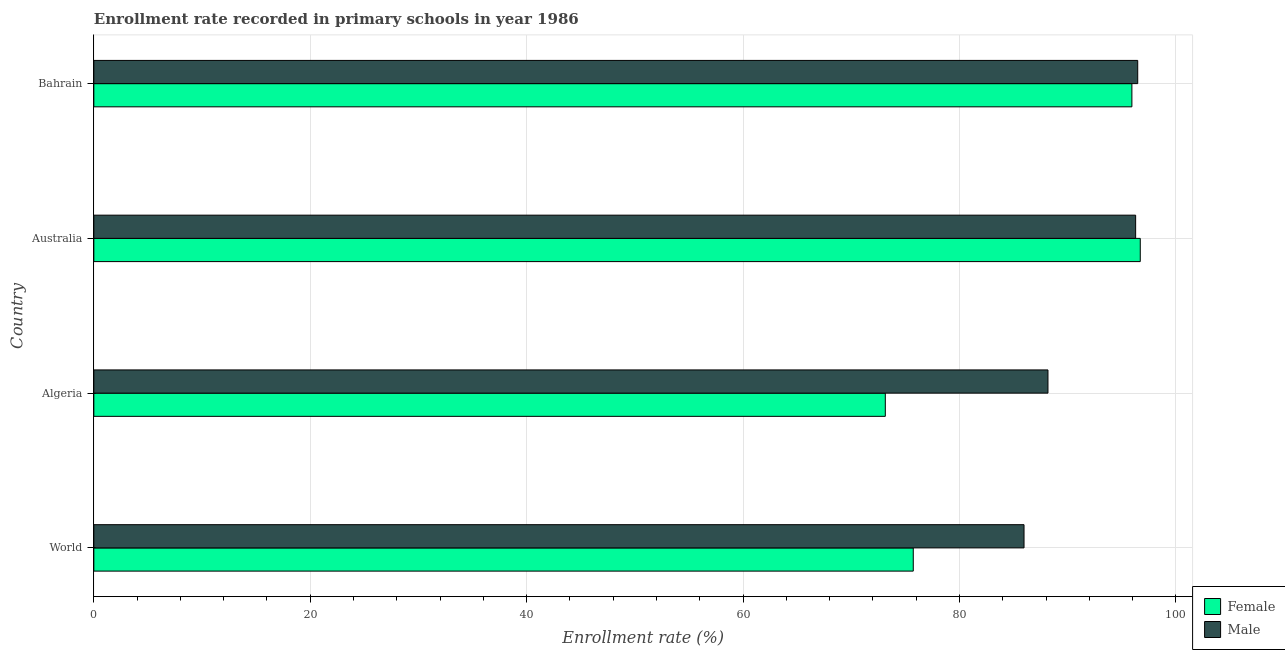How many groups of bars are there?
Make the answer very short. 4. What is the label of the 4th group of bars from the top?
Provide a succinct answer. World. What is the enrollment rate of male students in World?
Provide a succinct answer. 85.96. Across all countries, what is the maximum enrollment rate of male students?
Keep it short and to the point. 96.47. Across all countries, what is the minimum enrollment rate of male students?
Offer a very short reply. 85.96. In which country was the enrollment rate of male students maximum?
Your answer should be very brief. Bahrain. In which country was the enrollment rate of female students minimum?
Your answer should be compact. Algeria. What is the total enrollment rate of male students in the graph?
Offer a very short reply. 366.88. What is the difference between the enrollment rate of female students in Algeria and that in World?
Give a very brief answer. -2.58. What is the difference between the enrollment rate of female students in Australia and the enrollment rate of male students in Algeria?
Offer a terse response. 8.53. What is the average enrollment rate of male students per country?
Make the answer very short. 91.72. What is the difference between the enrollment rate of female students and enrollment rate of male students in Australia?
Your answer should be very brief. 0.43. In how many countries, is the enrollment rate of female students greater than 68 %?
Offer a terse response. 4. What is the ratio of the enrollment rate of female students in Australia to that in World?
Offer a very short reply. 1.28. Is the enrollment rate of male students in Bahrain less than that in World?
Make the answer very short. No. What is the difference between the highest and the second highest enrollment rate of male students?
Make the answer very short. 0.19. What is the difference between the highest and the lowest enrollment rate of female students?
Give a very brief answer. 23.56. In how many countries, is the enrollment rate of male students greater than the average enrollment rate of male students taken over all countries?
Make the answer very short. 2. Is the sum of the enrollment rate of female students in Algeria and Bahrain greater than the maximum enrollment rate of male students across all countries?
Make the answer very short. Yes. Are all the bars in the graph horizontal?
Provide a short and direct response. Yes. How many countries are there in the graph?
Offer a terse response. 4. How many legend labels are there?
Offer a very short reply. 2. How are the legend labels stacked?
Make the answer very short. Vertical. What is the title of the graph?
Ensure brevity in your answer.  Enrollment rate recorded in primary schools in year 1986. What is the label or title of the X-axis?
Make the answer very short. Enrollment rate (%). What is the label or title of the Y-axis?
Offer a very short reply. Country. What is the Enrollment rate (%) of Female in World?
Give a very brief answer. 75.73. What is the Enrollment rate (%) in Male in World?
Your answer should be compact. 85.96. What is the Enrollment rate (%) in Female in Algeria?
Offer a terse response. 73.14. What is the Enrollment rate (%) of Male in Algeria?
Offer a terse response. 88.17. What is the Enrollment rate (%) of Female in Australia?
Your response must be concise. 96.7. What is the Enrollment rate (%) in Male in Australia?
Your response must be concise. 96.28. What is the Enrollment rate (%) in Female in Bahrain?
Keep it short and to the point. 95.93. What is the Enrollment rate (%) of Male in Bahrain?
Provide a succinct answer. 96.47. Across all countries, what is the maximum Enrollment rate (%) of Female?
Make the answer very short. 96.7. Across all countries, what is the maximum Enrollment rate (%) in Male?
Your response must be concise. 96.47. Across all countries, what is the minimum Enrollment rate (%) in Female?
Offer a very short reply. 73.14. Across all countries, what is the minimum Enrollment rate (%) in Male?
Keep it short and to the point. 85.96. What is the total Enrollment rate (%) of Female in the graph?
Keep it short and to the point. 341.5. What is the total Enrollment rate (%) in Male in the graph?
Keep it short and to the point. 366.88. What is the difference between the Enrollment rate (%) in Female in World and that in Algeria?
Give a very brief answer. 2.58. What is the difference between the Enrollment rate (%) in Male in World and that in Algeria?
Provide a succinct answer. -2.21. What is the difference between the Enrollment rate (%) in Female in World and that in Australia?
Make the answer very short. -20.98. What is the difference between the Enrollment rate (%) in Male in World and that in Australia?
Your response must be concise. -10.31. What is the difference between the Enrollment rate (%) in Female in World and that in Bahrain?
Provide a succinct answer. -20.2. What is the difference between the Enrollment rate (%) of Male in World and that in Bahrain?
Ensure brevity in your answer.  -10.51. What is the difference between the Enrollment rate (%) in Female in Algeria and that in Australia?
Offer a very short reply. -23.56. What is the difference between the Enrollment rate (%) of Male in Algeria and that in Australia?
Your response must be concise. -8.1. What is the difference between the Enrollment rate (%) of Female in Algeria and that in Bahrain?
Offer a very short reply. -22.79. What is the difference between the Enrollment rate (%) in Male in Algeria and that in Bahrain?
Offer a very short reply. -8.29. What is the difference between the Enrollment rate (%) of Female in Australia and that in Bahrain?
Your response must be concise. 0.77. What is the difference between the Enrollment rate (%) of Male in Australia and that in Bahrain?
Give a very brief answer. -0.19. What is the difference between the Enrollment rate (%) in Female in World and the Enrollment rate (%) in Male in Algeria?
Provide a succinct answer. -12.45. What is the difference between the Enrollment rate (%) of Female in World and the Enrollment rate (%) of Male in Australia?
Provide a short and direct response. -20.55. What is the difference between the Enrollment rate (%) in Female in World and the Enrollment rate (%) in Male in Bahrain?
Your answer should be compact. -20.74. What is the difference between the Enrollment rate (%) in Female in Algeria and the Enrollment rate (%) in Male in Australia?
Offer a terse response. -23.13. What is the difference between the Enrollment rate (%) in Female in Algeria and the Enrollment rate (%) in Male in Bahrain?
Make the answer very short. -23.33. What is the difference between the Enrollment rate (%) of Female in Australia and the Enrollment rate (%) of Male in Bahrain?
Your response must be concise. 0.24. What is the average Enrollment rate (%) in Female per country?
Keep it short and to the point. 85.37. What is the average Enrollment rate (%) of Male per country?
Your answer should be compact. 91.72. What is the difference between the Enrollment rate (%) in Female and Enrollment rate (%) in Male in World?
Provide a short and direct response. -10.23. What is the difference between the Enrollment rate (%) in Female and Enrollment rate (%) in Male in Algeria?
Provide a succinct answer. -15.03. What is the difference between the Enrollment rate (%) in Female and Enrollment rate (%) in Male in Australia?
Offer a very short reply. 0.43. What is the difference between the Enrollment rate (%) of Female and Enrollment rate (%) of Male in Bahrain?
Provide a succinct answer. -0.54. What is the ratio of the Enrollment rate (%) of Female in World to that in Algeria?
Provide a short and direct response. 1.04. What is the ratio of the Enrollment rate (%) of Male in World to that in Algeria?
Offer a very short reply. 0.97. What is the ratio of the Enrollment rate (%) in Female in World to that in Australia?
Offer a terse response. 0.78. What is the ratio of the Enrollment rate (%) in Male in World to that in Australia?
Ensure brevity in your answer.  0.89. What is the ratio of the Enrollment rate (%) of Female in World to that in Bahrain?
Your response must be concise. 0.79. What is the ratio of the Enrollment rate (%) of Male in World to that in Bahrain?
Offer a terse response. 0.89. What is the ratio of the Enrollment rate (%) in Female in Algeria to that in Australia?
Keep it short and to the point. 0.76. What is the ratio of the Enrollment rate (%) of Male in Algeria to that in Australia?
Make the answer very short. 0.92. What is the ratio of the Enrollment rate (%) of Female in Algeria to that in Bahrain?
Your answer should be compact. 0.76. What is the ratio of the Enrollment rate (%) of Male in Algeria to that in Bahrain?
Offer a very short reply. 0.91. What is the difference between the highest and the second highest Enrollment rate (%) in Female?
Provide a short and direct response. 0.77. What is the difference between the highest and the second highest Enrollment rate (%) of Male?
Offer a very short reply. 0.19. What is the difference between the highest and the lowest Enrollment rate (%) of Female?
Your response must be concise. 23.56. What is the difference between the highest and the lowest Enrollment rate (%) in Male?
Your response must be concise. 10.51. 